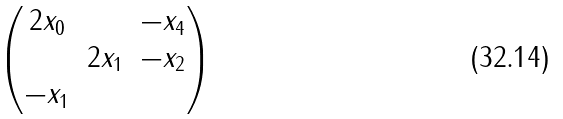<formula> <loc_0><loc_0><loc_500><loc_500>\begin{pmatrix} 2 x _ { 0 } & & - x _ { 4 } \\ & 2 x _ { 1 } & - x _ { 2 } \\ - x _ { 1 } & & \end{pmatrix}</formula> 